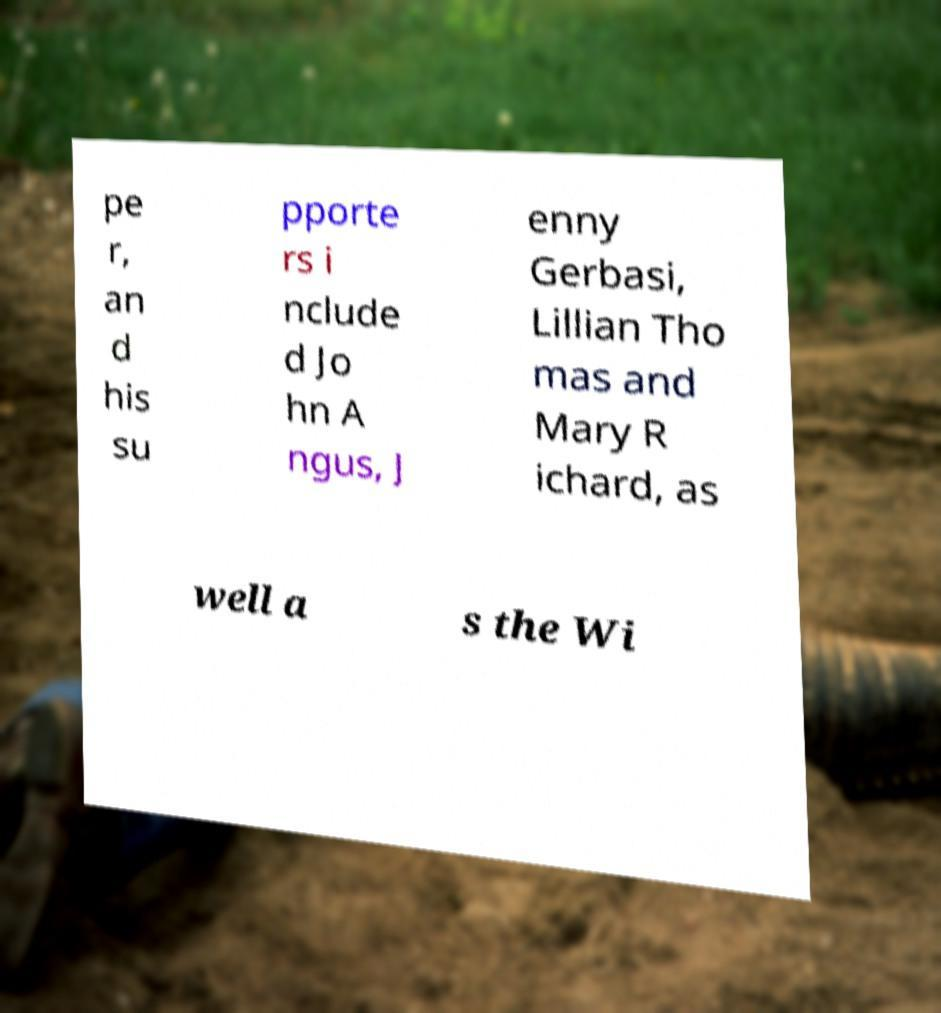Can you read and provide the text displayed in the image?This photo seems to have some interesting text. Can you extract and type it out for me? pe r, an d his su pporte rs i nclude d Jo hn A ngus, J enny Gerbasi, Lillian Tho mas and Mary R ichard, as well a s the Wi 